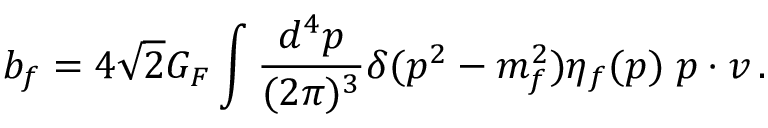Convert formula to latex. <formula><loc_0><loc_0><loc_500><loc_500>b _ { f } = 4 \sqrt { 2 } G _ { F } \int \frac { d ^ { 4 } p } { ( 2 \pi ) ^ { 3 } } \delta ( p ^ { 2 } - m _ { f } ^ { 2 } ) \eta _ { f } ( p ) \, p \cdot v \, .</formula> 